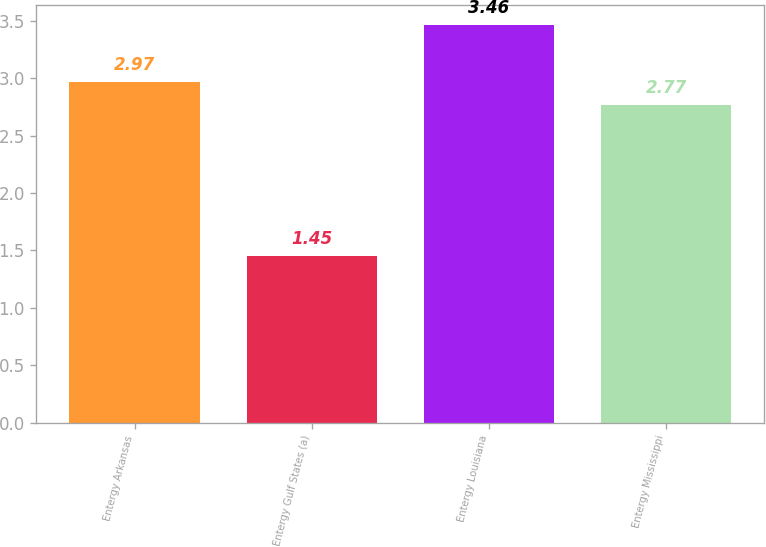Convert chart to OTSL. <chart><loc_0><loc_0><loc_500><loc_500><bar_chart><fcel>Entergy Arkansas<fcel>Entergy Gulf States (a)<fcel>Entergy Louisiana<fcel>Entergy Mississippi<nl><fcel>2.97<fcel>1.45<fcel>3.46<fcel>2.77<nl></chart> 